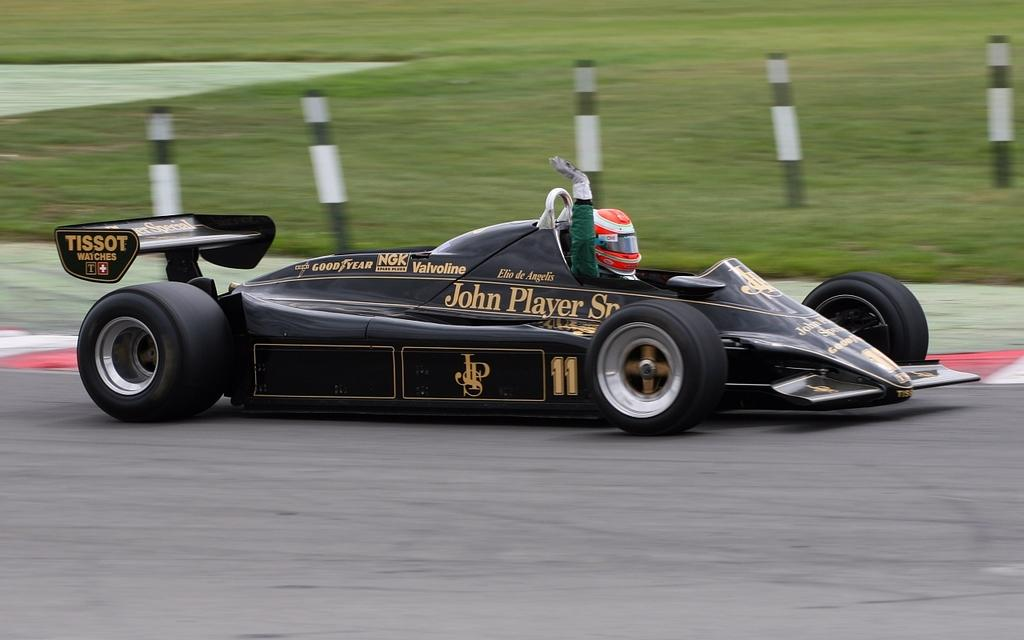Who is present in the image? There is a person in the image. What is the person wearing? The person is wearing a helmet. What type of vehicle is in the image? There is a sports car in the image. Where is the sports car located? The sports car is on the road. What structures can be seen in the image? There are poles visible in the image. What type of natural environment is present in the image? There is grass in the image. What type of match is being played in the image? There is no match being played in the image; it features a person wearing a helmet, a sports car on the road, poles, and grass. How does the lock on the sports car work in the image? There is no lock on the sports car visible in the image. 